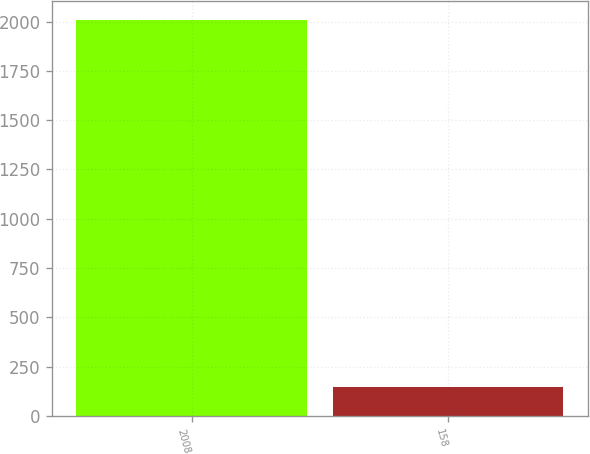<chart> <loc_0><loc_0><loc_500><loc_500><bar_chart><fcel>2008<fcel>158<nl><fcel>2007<fcel>145<nl></chart> 